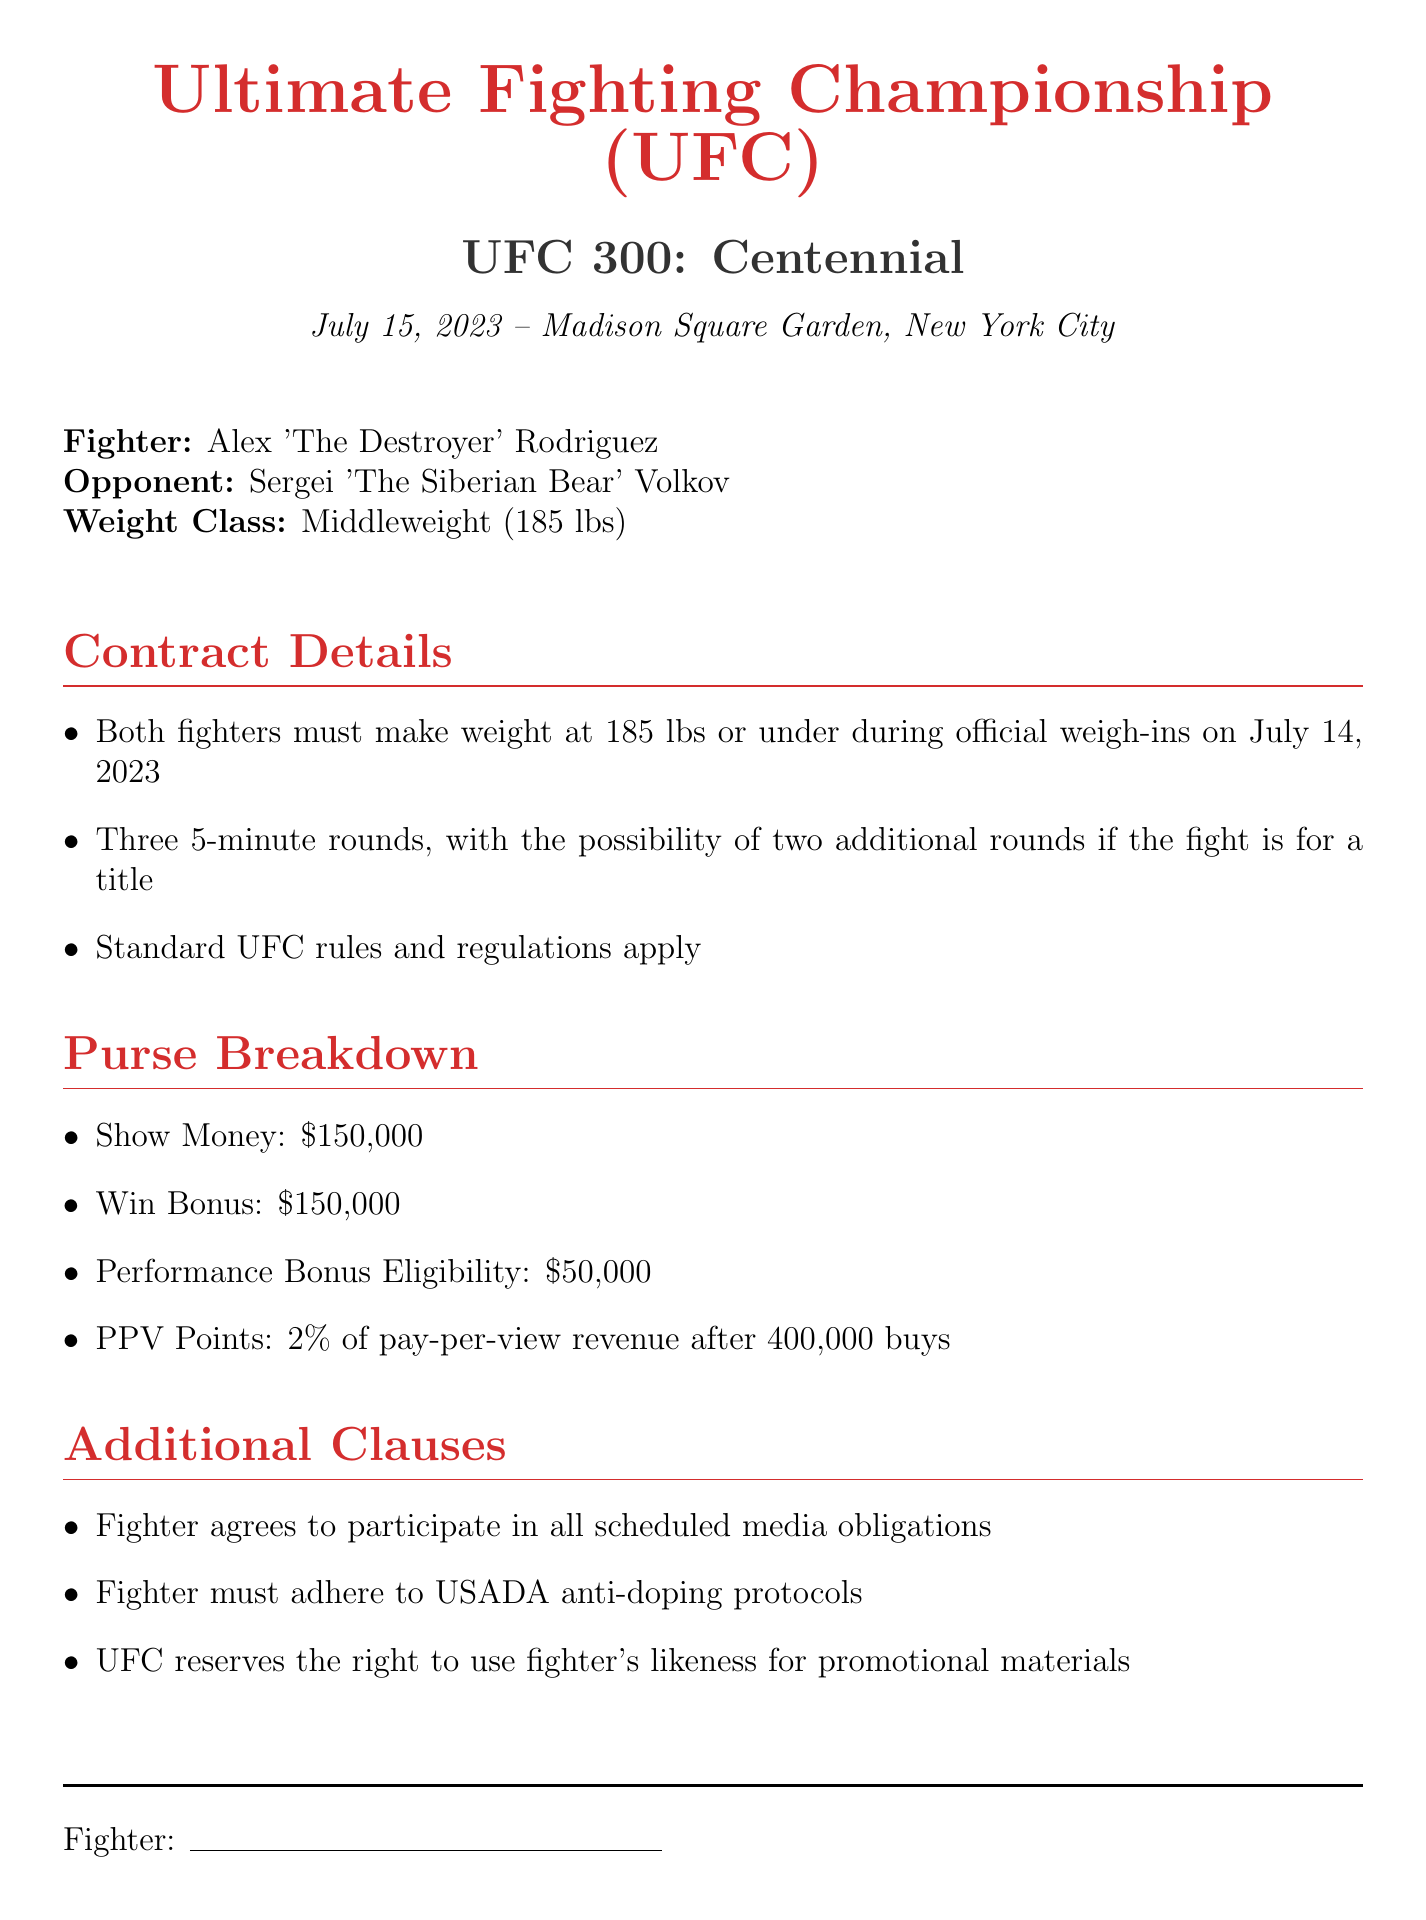what is the fight date? The fight date is mentioned in the document clearly under the event details.
Answer: July 15, 2023 who is the opponent? The opponent's name is specified in the fighter details.
Answer: Sergei 'The Siberian Bear' Volkov what is the weight class? The weight class is explicitly stated in the fighter details section.
Answer: Middleweight (185 lbs) what is the show money amount? The show money amount is listed under the purse breakdown section.
Answer: $150,000 how many rounds is the fight scheduled for? The number of rounds is specified in the contract details section, indicating the fight format.
Answer: Three 5-minute rounds what is the performance bonus eligibility? The performance bonus eligibility is outlined in the purse breakdown section.
Answer: $50,000 what percentage of pay-per-view revenue do fighters receive after 400,000 buys? This percentage is mentioned in the purse breakdown section regarding PPV points.
Answer: 2% what is a requirement for the fighters regarding media? The document notes specific responsibilities for the fighters concerning media commitments.
Answer: Participate in all scheduled media obligations who must adhere to USADA protocols? The responsibility regarding USADA protocols is mentioned in the additional clauses.
Answer: Fighter 